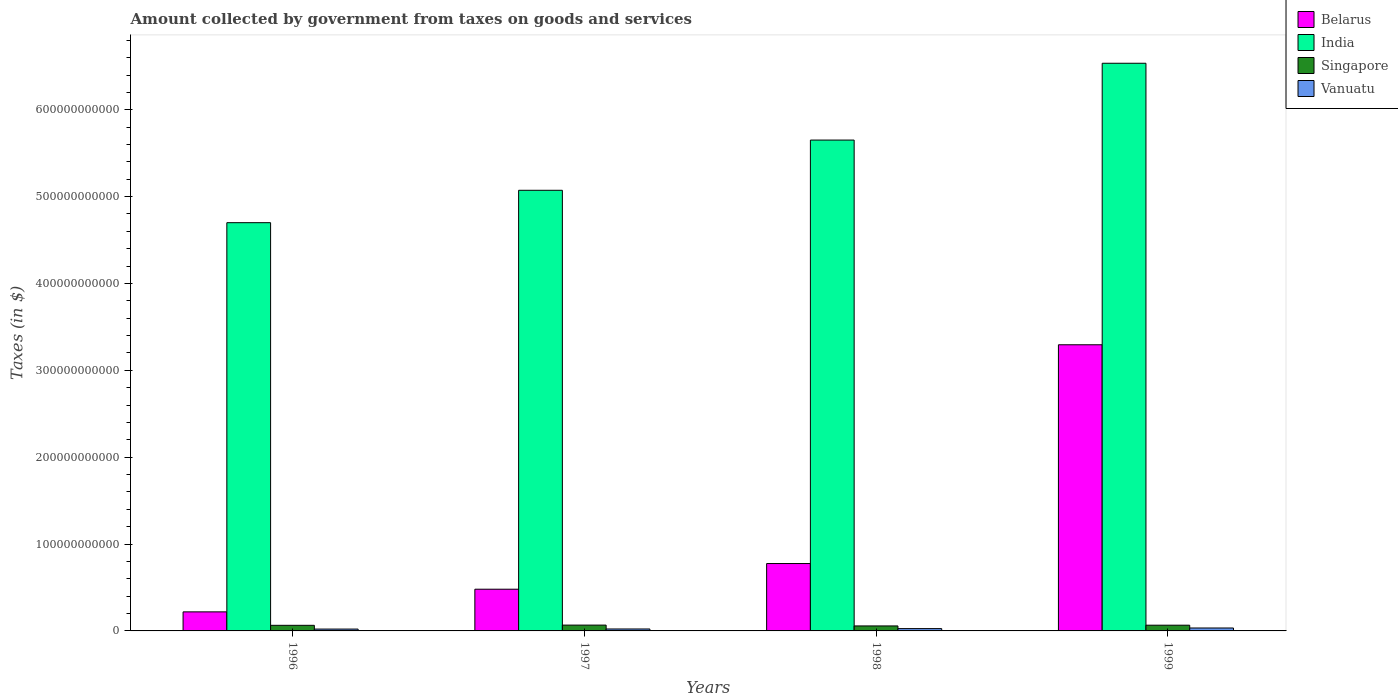How many different coloured bars are there?
Ensure brevity in your answer.  4. Are the number of bars per tick equal to the number of legend labels?
Keep it short and to the point. Yes. How many bars are there on the 3rd tick from the right?
Offer a terse response. 4. What is the amount collected by government from taxes on goods and services in Singapore in 1999?
Give a very brief answer. 6.60e+09. Across all years, what is the maximum amount collected by government from taxes on goods and services in Vanuatu?
Your response must be concise. 3.37e+09. Across all years, what is the minimum amount collected by government from taxes on goods and services in Vanuatu?
Offer a terse response. 2.12e+09. What is the total amount collected by government from taxes on goods and services in India in the graph?
Offer a terse response. 2.20e+12. What is the difference between the amount collected by government from taxes on goods and services in India in 1997 and that in 1999?
Provide a succinct answer. -1.46e+11. What is the difference between the amount collected by government from taxes on goods and services in Singapore in 1997 and the amount collected by government from taxes on goods and services in India in 1996?
Give a very brief answer. -4.63e+11. What is the average amount collected by government from taxes on goods and services in Belarus per year?
Provide a short and direct response. 1.19e+11. In the year 1998, what is the difference between the amount collected by government from taxes on goods and services in Singapore and amount collected by government from taxes on goods and services in Vanuatu?
Give a very brief answer. 3.08e+09. What is the ratio of the amount collected by government from taxes on goods and services in India in 1998 to that in 1999?
Provide a succinct answer. 0.86. What is the difference between the highest and the second highest amount collected by government from taxes on goods and services in Vanuatu?
Offer a very short reply. 7.00e+08. What is the difference between the highest and the lowest amount collected by government from taxes on goods and services in Belarus?
Your answer should be very brief. 3.07e+11. In how many years, is the amount collected by government from taxes on goods and services in Vanuatu greater than the average amount collected by government from taxes on goods and services in Vanuatu taken over all years?
Offer a very short reply. 2. Is it the case that in every year, the sum of the amount collected by government from taxes on goods and services in India and amount collected by government from taxes on goods and services in Singapore is greater than the sum of amount collected by government from taxes on goods and services in Vanuatu and amount collected by government from taxes on goods and services in Belarus?
Your answer should be very brief. Yes. What does the 3rd bar from the left in 1997 represents?
Your answer should be very brief. Singapore. What does the 4th bar from the right in 1996 represents?
Provide a succinct answer. Belarus. Is it the case that in every year, the sum of the amount collected by government from taxes on goods and services in India and amount collected by government from taxes on goods and services in Singapore is greater than the amount collected by government from taxes on goods and services in Vanuatu?
Provide a succinct answer. Yes. How many years are there in the graph?
Make the answer very short. 4. What is the difference between two consecutive major ticks on the Y-axis?
Offer a terse response. 1.00e+11. Are the values on the major ticks of Y-axis written in scientific E-notation?
Your answer should be very brief. No. How are the legend labels stacked?
Ensure brevity in your answer.  Vertical. What is the title of the graph?
Provide a short and direct response. Amount collected by government from taxes on goods and services. What is the label or title of the Y-axis?
Your answer should be compact. Taxes (in $). What is the Taxes (in $) in Belarus in 1996?
Your answer should be compact. 2.19e+1. What is the Taxes (in $) in India in 1996?
Your answer should be very brief. 4.70e+11. What is the Taxes (in $) of Singapore in 1996?
Your answer should be compact. 6.45e+09. What is the Taxes (in $) in Vanuatu in 1996?
Ensure brevity in your answer.  2.12e+09. What is the Taxes (in $) of Belarus in 1997?
Offer a terse response. 4.80e+1. What is the Taxes (in $) in India in 1997?
Your response must be concise. 5.07e+11. What is the Taxes (in $) in Singapore in 1997?
Give a very brief answer. 6.70e+09. What is the Taxes (in $) of Vanuatu in 1997?
Your answer should be very brief. 2.23e+09. What is the Taxes (in $) in Belarus in 1998?
Ensure brevity in your answer.  7.76e+1. What is the Taxes (in $) of India in 1998?
Offer a terse response. 5.65e+11. What is the Taxes (in $) in Singapore in 1998?
Your answer should be very brief. 5.75e+09. What is the Taxes (in $) in Vanuatu in 1998?
Ensure brevity in your answer.  2.67e+09. What is the Taxes (in $) of Belarus in 1999?
Keep it short and to the point. 3.29e+11. What is the Taxes (in $) in India in 1999?
Make the answer very short. 6.54e+11. What is the Taxes (in $) in Singapore in 1999?
Keep it short and to the point. 6.60e+09. What is the Taxes (in $) of Vanuatu in 1999?
Your answer should be compact. 3.37e+09. Across all years, what is the maximum Taxes (in $) in Belarus?
Offer a terse response. 3.29e+11. Across all years, what is the maximum Taxes (in $) in India?
Provide a succinct answer. 6.54e+11. Across all years, what is the maximum Taxes (in $) of Singapore?
Provide a succinct answer. 6.70e+09. Across all years, what is the maximum Taxes (in $) in Vanuatu?
Offer a terse response. 3.37e+09. Across all years, what is the minimum Taxes (in $) of Belarus?
Your response must be concise. 2.19e+1. Across all years, what is the minimum Taxes (in $) of India?
Provide a succinct answer. 4.70e+11. Across all years, what is the minimum Taxes (in $) in Singapore?
Offer a terse response. 5.75e+09. Across all years, what is the minimum Taxes (in $) of Vanuatu?
Your answer should be compact. 2.12e+09. What is the total Taxes (in $) in Belarus in the graph?
Provide a succinct answer. 4.77e+11. What is the total Taxes (in $) in India in the graph?
Offer a very short reply. 2.20e+12. What is the total Taxes (in $) in Singapore in the graph?
Offer a terse response. 2.55e+1. What is the total Taxes (in $) in Vanuatu in the graph?
Your response must be concise. 1.04e+1. What is the difference between the Taxes (in $) in Belarus in 1996 and that in 1997?
Make the answer very short. -2.61e+1. What is the difference between the Taxes (in $) of India in 1996 and that in 1997?
Give a very brief answer. -3.73e+1. What is the difference between the Taxes (in $) of Singapore in 1996 and that in 1997?
Give a very brief answer. -2.50e+08. What is the difference between the Taxes (in $) in Vanuatu in 1996 and that in 1997?
Keep it short and to the point. -1.05e+08. What is the difference between the Taxes (in $) in Belarus in 1996 and that in 1998?
Provide a short and direct response. -5.56e+1. What is the difference between the Taxes (in $) of India in 1996 and that in 1998?
Provide a short and direct response. -9.51e+1. What is the difference between the Taxes (in $) of Singapore in 1996 and that in 1998?
Offer a very short reply. 7.00e+08. What is the difference between the Taxes (in $) in Vanuatu in 1996 and that in 1998?
Provide a succinct answer. -5.44e+08. What is the difference between the Taxes (in $) in Belarus in 1996 and that in 1999?
Provide a succinct answer. -3.07e+11. What is the difference between the Taxes (in $) in India in 1996 and that in 1999?
Give a very brief answer. -1.84e+11. What is the difference between the Taxes (in $) of Singapore in 1996 and that in 1999?
Provide a short and direct response. -1.49e+08. What is the difference between the Taxes (in $) in Vanuatu in 1996 and that in 1999?
Offer a very short reply. -1.24e+09. What is the difference between the Taxes (in $) in Belarus in 1997 and that in 1998?
Your response must be concise. -2.96e+1. What is the difference between the Taxes (in $) in India in 1997 and that in 1998?
Give a very brief answer. -5.78e+1. What is the difference between the Taxes (in $) in Singapore in 1997 and that in 1998?
Ensure brevity in your answer.  9.50e+08. What is the difference between the Taxes (in $) of Vanuatu in 1997 and that in 1998?
Offer a terse response. -4.39e+08. What is the difference between the Taxes (in $) in Belarus in 1997 and that in 1999?
Keep it short and to the point. -2.81e+11. What is the difference between the Taxes (in $) in India in 1997 and that in 1999?
Ensure brevity in your answer.  -1.46e+11. What is the difference between the Taxes (in $) of Singapore in 1997 and that in 1999?
Provide a succinct answer. 1.01e+08. What is the difference between the Taxes (in $) of Vanuatu in 1997 and that in 1999?
Your response must be concise. -1.14e+09. What is the difference between the Taxes (in $) of Belarus in 1998 and that in 1999?
Provide a succinct answer. -2.52e+11. What is the difference between the Taxes (in $) in India in 1998 and that in 1999?
Make the answer very short. -8.84e+1. What is the difference between the Taxes (in $) in Singapore in 1998 and that in 1999?
Your answer should be compact. -8.49e+08. What is the difference between the Taxes (in $) of Vanuatu in 1998 and that in 1999?
Provide a short and direct response. -7.00e+08. What is the difference between the Taxes (in $) of Belarus in 1996 and the Taxes (in $) of India in 1997?
Give a very brief answer. -4.85e+11. What is the difference between the Taxes (in $) in Belarus in 1996 and the Taxes (in $) in Singapore in 1997?
Provide a succinct answer. 1.52e+1. What is the difference between the Taxes (in $) of Belarus in 1996 and the Taxes (in $) of Vanuatu in 1997?
Provide a succinct answer. 1.97e+1. What is the difference between the Taxes (in $) in India in 1996 and the Taxes (in $) in Singapore in 1997?
Your answer should be very brief. 4.63e+11. What is the difference between the Taxes (in $) in India in 1996 and the Taxes (in $) in Vanuatu in 1997?
Provide a short and direct response. 4.68e+11. What is the difference between the Taxes (in $) of Singapore in 1996 and the Taxes (in $) of Vanuatu in 1997?
Make the answer very short. 4.22e+09. What is the difference between the Taxes (in $) of Belarus in 1996 and the Taxes (in $) of India in 1998?
Offer a very short reply. -5.43e+11. What is the difference between the Taxes (in $) of Belarus in 1996 and the Taxes (in $) of Singapore in 1998?
Offer a very short reply. 1.62e+1. What is the difference between the Taxes (in $) in Belarus in 1996 and the Taxes (in $) in Vanuatu in 1998?
Ensure brevity in your answer.  1.93e+1. What is the difference between the Taxes (in $) of India in 1996 and the Taxes (in $) of Singapore in 1998?
Provide a short and direct response. 4.64e+11. What is the difference between the Taxes (in $) in India in 1996 and the Taxes (in $) in Vanuatu in 1998?
Your response must be concise. 4.67e+11. What is the difference between the Taxes (in $) in Singapore in 1996 and the Taxes (in $) in Vanuatu in 1998?
Your answer should be compact. 3.78e+09. What is the difference between the Taxes (in $) of Belarus in 1996 and the Taxes (in $) of India in 1999?
Provide a succinct answer. -6.32e+11. What is the difference between the Taxes (in $) of Belarus in 1996 and the Taxes (in $) of Singapore in 1999?
Your answer should be compact. 1.53e+1. What is the difference between the Taxes (in $) of Belarus in 1996 and the Taxes (in $) of Vanuatu in 1999?
Your answer should be compact. 1.86e+1. What is the difference between the Taxes (in $) in India in 1996 and the Taxes (in $) in Singapore in 1999?
Make the answer very short. 4.63e+11. What is the difference between the Taxes (in $) in India in 1996 and the Taxes (in $) in Vanuatu in 1999?
Ensure brevity in your answer.  4.67e+11. What is the difference between the Taxes (in $) of Singapore in 1996 and the Taxes (in $) of Vanuatu in 1999?
Give a very brief answer. 3.08e+09. What is the difference between the Taxes (in $) in Belarus in 1997 and the Taxes (in $) in India in 1998?
Make the answer very short. -5.17e+11. What is the difference between the Taxes (in $) of Belarus in 1997 and the Taxes (in $) of Singapore in 1998?
Provide a succinct answer. 4.23e+1. What is the difference between the Taxes (in $) in Belarus in 1997 and the Taxes (in $) in Vanuatu in 1998?
Make the answer very short. 4.54e+1. What is the difference between the Taxes (in $) in India in 1997 and the Taxes (in $) in Singapore in 1998?
Give a very brief answer. 5.02e+11. What is the difference between the Taxes (in $) in India in 1997 and the Taxes (in $) in Vanuatu in 1998?
Your answer should be compact. 5.05e+11. What is the difference between the Taxes (in $) in Singapore in 1997 and the Taxes (in $) in Vanuatu in 1998?
Offer a terse response. 4.03e+09. What is the difference between the Taxes (in $) of Belarus in 1997 and the Taxes (in $) of India in 1999?
Your response must be concise. -6.05e+11. What is the difference between the Taxes (in $) of Belarus in 1997 and the Taxes (in $) of Singapore in 1999?
Give a very brief answer. 4.14e+1. What is the difference between the Taxes (in $) in Belarus in 1997 and the Taxes (in $) in Vanuatu in 1999?
Your response must be concise. 4.47e+1. What is the difference between the Taxes (in $) of India in 1997 and the Taxes (in $) of Singapore in 1999?
Your answer should be very brief. 5.01e+11. What is the difference between the Taxes (in $) in India in 1997 and the Taxes (in $) in Vanuatu in 1999?
Offer a very short reply. 5.04e+11. What is the difference between the Taxes (in $) in Singapore in 1997 and the Taxes (in $) in Vanuatu in 1999?
Offer a terse response. 3.33e+09. What is the difference between the Taxes (in $) of Belarus in 1998 and the Taxes (in $) of India in 1999?
Make the answer very short. -5.76e+11. What is the difference between the Taxes (in $) of Belarus in 1998 and the Taxes (in $) of Singapore in 1999?
Provide a succinct answer. 7.10e+1. What is the difference between the Taxes (in $) in Belarus in 1998 and the Taxes (in $) in Vanuatu in 1999?
Keep it short and to the point. 7.42e+1. What is the difference between the Taxes (in $) of India in 1998 and the Taxes (in $) of Singapore in 1999?
Your answer should be very brief. 5.58e+11. What is the difference between the Taxes (in $) in India in 1998 and the Taxes (in $) in Vanuatu in 1999?
Your answer should be very brief. 5.62e+11. What is the difference between the Taxes (in $) of Singapore in 1998 and the Taxes (in $) of Vanuatu in 1999?
Your answer should be very brief. 2.38e+09. What is the average Taxes (in $) in Belarus per year?
Make the answer very short. 1.19e+11. What is the average Taxes (in $) in India per year?
Your answer should be very brief. 5.49e+11. What is the average Taxes (in $) of Singapore per year?
Give a very brief answer. 6.37e+09. What is the average Taxes (in $) in Vanuatu per year?
Provide a succinct answer. 2.60e+09. In the year 1996, what is the difference between the Taxes (in $) of Belarus and Taxes (in $) of India?
Keep it short and to the point. -4.48e+11. In the year 1996, what is the difference between the Taxes (in $) of Belarus and Taxes (in $) of Singapore?
Ensure brevity in your answer.  1.55e+1. In the year 1996, what is the difference between the Taxes (in $) in Belarus and Taxes (in $) in Vanuatu?
Offer a terse response. 1.98e+1. In the year 1996, what is the difference between the Taxes (in $) of India and Taxes (in $) of Singapore?
Keep it short and to the point. 4.64e+11. In the year 1996, what is the difference between the Taxes (in $) of India and Taxes (in $) of Vanuatu?
Give a very brief answer. 4.68e+11. In the year 1996, what is the difference between the Taxes (in $) in Singapore and Taxes (in $) in Vanuatu?
Provide a succinct answer. 4.32e+09. In the year 1997, what is the difference between the Taxes (in $) in Belarus and Taxes (in $) in India?
Provide a succinct answer. -4.59e+11. In the year 1997, what is the difference between the Taxes (in $) in Belarus and Taxes (in $) in Singapore?
Give a very brief answer. 4.13e+1. In the year 1997, what is the difference between the Taxes (in $) in Belarus and Taxes (in $) in Vanuatu?
Offer a terse response. 4.58e+1. In the year 1997, what is the difference between the Taxes (in $) of India and Taxes (in $) of Singapore?
Give a very brief answer. 5.01e+11. In the year 1997, what is the difference between the Taxes (in $) in India and Taxes (in $) in Vanuatu?
Provide a short and direct response. 5.05e+11. In the year 1997, what is the difference between the Taxes (in $) of Singapore and Taxes (in $) of Vanuatu?
Ensure brevity in your answer.  4.47e+09. In the year 1998, what is the difference between the Taxes (in $) in Belarus and Taxes (in $) in India?
Provide a succinct answer. -4.88e+11. In the year 1998, what is the difference between the Taxes (in $) of Belarus and Taxes (in $) of Singapore?
Offer a terse response. 7.18e+1. In the year 1998, what is the difference between the Taxes (in $) of Belarus and Taxes (in $) of Vanuatu?
Your answer should be compact. 7.49e+1. In the year 1998, what is the difference between the Taxes (in $) of India and Taxes (in $) of Singapore?
Your answer should be very brief. 5.59e+11. In the year 1998, what is the difference between the Taxes (in $) of India and Taxes (in $) of Vanuatu?
Ensure brevity in your answer.  5.62e+11. In the year 1998, what is the difference between the Taxes (in $) of Singapore and Taxes (in $) of Vanuatu?
Offer a terse response. 3.08e+09. In the year 1999, what is the difference between the Taxes (in $) of Belarus and Taxes (in $) of India?
Provide a succinct answer. -3.24e+11. In the year 1999, what is the difference between the Taxes (in $) in Belarus and Taxes (in $) in Singapore?
Make the answer very short. 3.23e+11. In the year 1999, what is the difference between the Taxes (in $) in Belarus and Taxes (in $) in Vanuatu?
Ensure brevity in your answer.  3.26e+11. In the year 1999, what is the difference between the Taxes (in $) of India and Taxes (in $) of Singapore?
Provide a short and direct response. 6.47e+11. In the year 1999, what is the difference between the Taxes (in $) of India and Taxes (in $) of Vanuatu?
Provide a short and direct response. 6.50e+11. In the year 1999, what is the difference between the Taxes (in $) in Singapore and Taxes (in $) in Vanuatu?
Your answer should be compact. 3.23e+09. What is the ratio of the Taxes (in $) of Belarus in 1996 to that in 1997?
Your response must be concise. 0.46. What is the ratio of the Taxes (in $) of India in 1996 to that in 1997?
Give a very brief answer. 0.93. What is the ratio of the Taxes (in $) in Singapore in 1996 to that in 1997?
Give a very brief answer. 0.96. What is the ratio of the Taxes (in $) of Vanuatu in 1996 to that in 1997?
Provide a short and direct response. 0.95. What is the ratio of the Taxes (in $) in Belarus in 1996 to that in 1998?
Ensure brevity in your answer.  0.28. What is the ratio of the Taxes (in $) in India in 1996 to that in 1998?
Keep it short and to the point. 0.83. What is the ratio of the Taxes (in $) in Singapore in 1996 to that in 1998?
Provide a short and direct response. 1.12. What is the ratio of the Taxes (in $) in Vanuatu in 1996 to that in 1998?
Provide a succinct answer. 0.8. What is the ratio of the Taxes (in $) in Belarus in 1996 to that in 1999?
Give a very brief answer. 0.07. What is the ratio of the Taxes (in $) of India in 1996 to that in 1999?
Provide a succinct answer. 0.72. What is the ratio of the Taxes (in $) in Singapore in 1996 to that in 1999?
Make the answer very short. 0.98. What is the ratio of the Taxes (in $) of Vanuatu in 1996 to that in 1999?
Offer a terse response. 0.63. What is the ratio of the Taxes (in $) of Belarus in 1997 to that in 1998?
Your answer should be compact. 0.62. What is the ratio of the Taxes (in $) of India in 1997 to that in 1998?
Your answer should be very brief. 0.9. What is the ratio of the Taxes (in $) of Singapore in 1997 to that in 1998?
Provide a succinct answer. 1.17. What is the ratio of the Taxes (in $) in Vanuatu in 1997 to that in 1998?
Your answer should be very brief. 0.84. What is the ratio of the Taxes (in $) in Belarus in 1997 to that in 1999?
Provide a short and direct response. 0.15. What is the ratio of the Taxes (in $) in India in 1997 to that in 1999?
Your answer should be compact. 0.78. What is the ratio of the Taxes (in $) in Singapore in 1997 to that in 1999?
Offer a terse response. 1.02. What is the ratio of the Taxes (in $) in Vanuatu in 1997 to that in 1999?
Your answer should be very brief. 0.66. What is the ratio of the Taxes (in $) in Belarus in 1998 to that in 1999?
Offer a very short reply. 0.24. What is the ratio of the Taxes (in $) of India in 1998 to that in 1999?
Make the answer very short. 0.86. What is the ratio of the Taxes (in $) in Singapore in 1998 to that in 1999?
Offer a very short reply. 0.87. What is the ratio of the Taxes (in $) in Vanuatu in 1998 to that in 1999?
Offer a very short reply. 0.79. What is the difference between the highest and the second highest Taxes (in $) in Belarus?
Ensure brevity in your answer.  2.52e+11. What is the difference between the highest and the second highest Taxes (in $) in India?
Offer a very short reply. 8.84e+1. What is the difference between the highest and the second highest Taxes (in $) of Singapore?
Provide a short and direct response. 1.01e+08. What is the difference between the highest and the second highest Taxes (in $) of Vanuatu?
Your response must be concise. 7.00e+08. What is the difference between the highest and the lowest Taxes (in $) in Belarus?
Offer a very short reply. 3.07e+11. What is the difference between the highest and the lowest Taxes (in $) in India?
Offer a terse response. 1.84e+11. What is the difference between the highest and the lowest Taxes (in $) of Singapore?
Keep it short and to the point. 9.50e+08. What is the difference between the highest and the lowest Taxes (in $) of Vanuatu?
Your answer should be compact. 1.24e+09. 